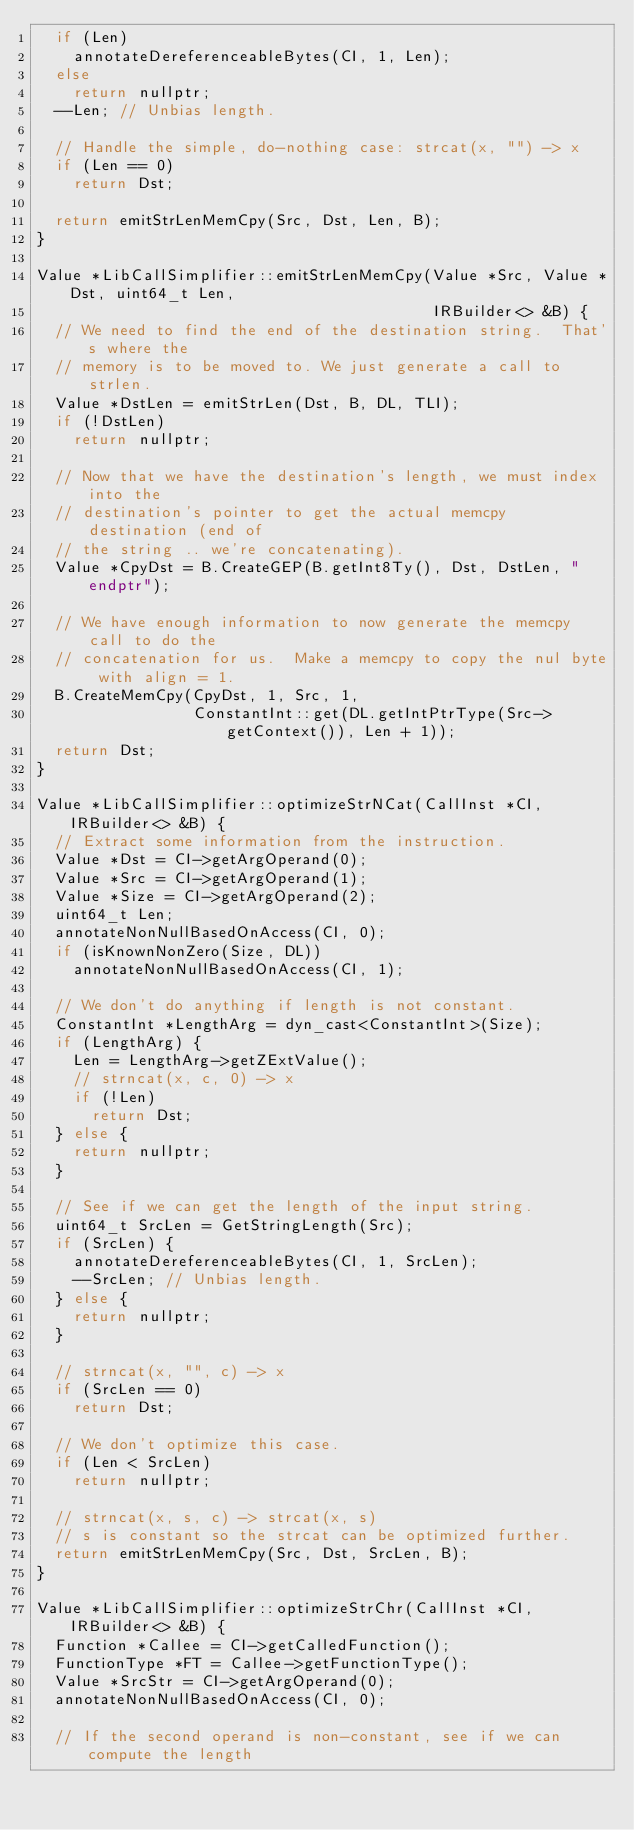Convert code to text. <code><loc_0><loc_0><loc_500><loc_500><_C++_>  if (Len)
    annotateDereferenceableBytes(CI, 1, Len);
  else
    return nullptr;
  --Len; // Unbias length.

  // Handle the simple, do-nothing case: strcat(x, "") -> x
  if (Len == 0)
    return Dst;

  return emitStrLenMemCpy(Src, Dst, Len, B);
}

Value *LibCallSimplifier::emitStrLenMemCpy(Value *Src, Value *Dst, uint64_t Len,
                                           IRBuilder<> &B) {
  // We need to find the end of the destination string.  That's where the
  // memory is to be moved to. We just generate a call to strlen.
  Value *DstLen = emitStrLen(Dst, B, DL, TLI);
  if (!DstLen)
    return nullptr;

  // Now that we have the destination's length, we must index into the
  // destination's pointer to get the actual memcpy destination (end of
  // the string .. we're concatenating).
  Value *CpyDst = B.CreateGEP(B.getInt8Ty(), Dst, DstLen, "endptr");

  // We have enough information to now generate the memcpy call to do the
  // concatenation for us.  Make a memcpy to copy the nul byte with align = 1.
  B.CreateMemCpy(CpyDst, 1, Src, 1,
                 ConstantInt::get(DL.getIntPtrType(Src->getContext()), Len + 1));
  return Dst;
}

Value *LibCallSimplifier::optimizeStrNCat(CallInst *CI, IRBuilder<> &B) {
  // Extract some information from the instruction.
  Value *Dst = CI->getArgOperand(0);
  Value *Src = CI->getArgOperand(1);
  Value *Size = CI->getArgOperand(2);
  uint64_t Len;
  annotateNonNullBasedOnAccess(CI, 0);
  if (isKnownNonZero(Size, DL))
    annotateNonNullBasedOnAccess(CI, 1);

  // We don't do anything if length is not constant.
  ConstantInt *LengthArg = dyn_cast<ConstantInt>(Size);
  if (LengthArg) {
    Len = LengthArg->getZExtValue();
    // strncat(x, c, 0) -> x
    if (!Len)
      return Dst;
  } else {
    return nullptr;
  }

  // See if we can get the length of the input string.
  uint64_t SrcLen = GetStringLength(Src);
  if (SrcLen) {
    annotateDereferenceableBytes(CI, 1, SrcLen);
    --SrcLen; // Unbias length.
  } else {
    return nullptr;
  }

  // strncat(x, "", c) -> x
  if (SrcLen == 0)
    return Dst;

  // We don't optimize this case.
  if (Len < SrcLen)
    return nullptr;

  // strncat(x, s, c) -> strcat(x, s)
  // s is constant so the strcat can be optimized further.
  return emitStrLenMemCpy(Src, Dst, SrcLen, B);
}

Value *LibCallSimplifier::optimizeStrChr(CallInst *CI, IRBuilder<> &B) {
  Function *Callee = CI->getCalledFunction();
  FunctionType *FT = Callee->getFunctionType();
  Value *SrcStr = CI->getArgOperand(0);
  annotateNonNullBasedOnAccess(CI, 0);

  // If the second operand is non-constant, see if we can compute the length</code> 